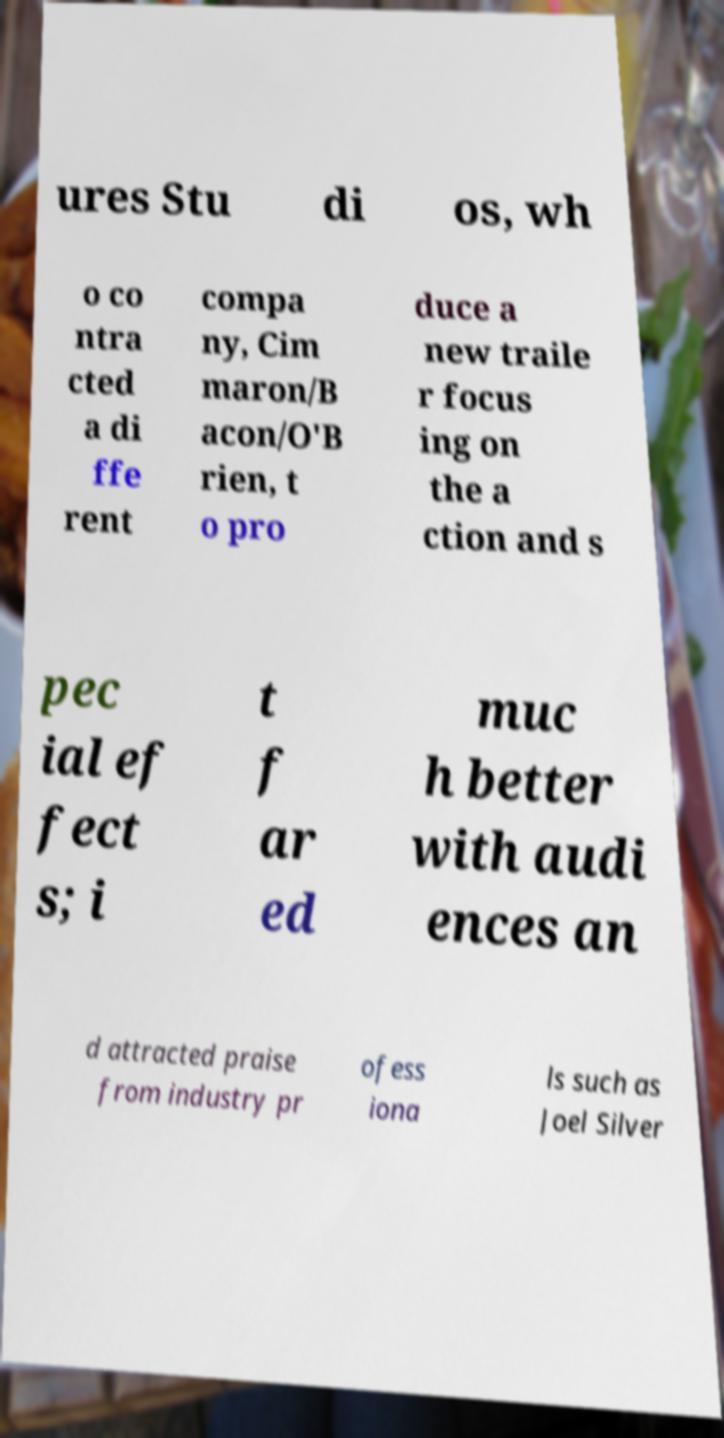Please read and relay the text visible in this image. What does it say? ures Stu di os, wh o co ntra cted a di ffe rent compa ny, Cim maron/B acon/O'B rien, t o pro duce a new traile r focus ing on the a ction and s pec ial ef fect s; i t f ar ed muc h better with audi ences an d attracted praise from industry pr ofess iona ls such as Joel Silver 